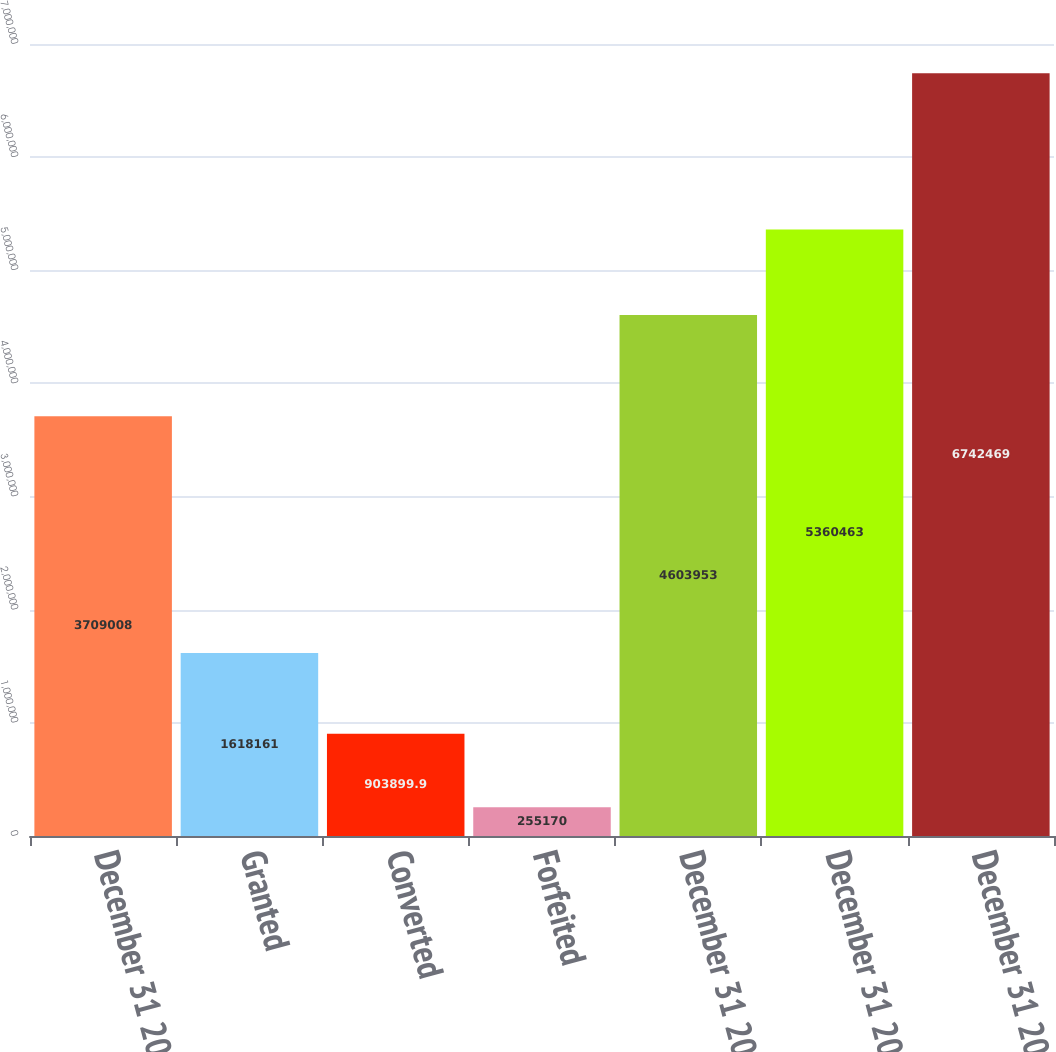Convert chart. <chart><loc_0><loc_0><loc_500><loc_500><bar_chart><fcel>December 31 2007<fcel>Granted<fcel>Converted<fcel>Forfeited<fcel>December 31 2008<fcel>December 31 2009<fcel>December 31 2010 (1)<nl><fcel>3.70901e+06<fcel>1.61816e+06<fcel>903900<fcel>255170<fcel>4.60395e+06<fcel>5.36046e+06<fcel>6.74247e+06<nl></chart> 